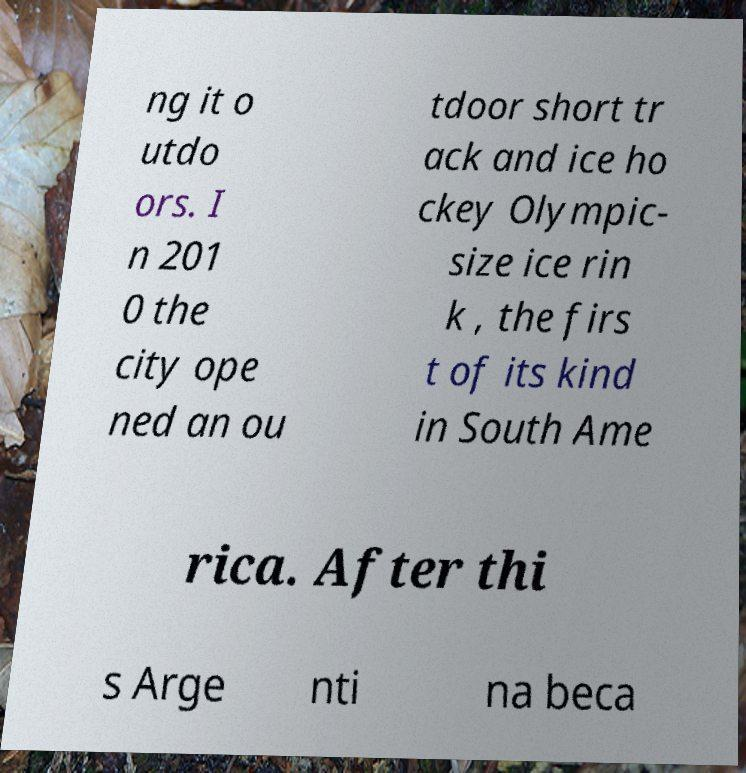Could you assist in decoding the text presented in this image and type it out clearly? ng it o utdo ors. I n 201 0 the city ope ned an ou tdoor short tr ack and ice ho ckey Olympic- size ice rin k , the firs t of its kind in South Ame rica. After thi s Arge nti na beca 